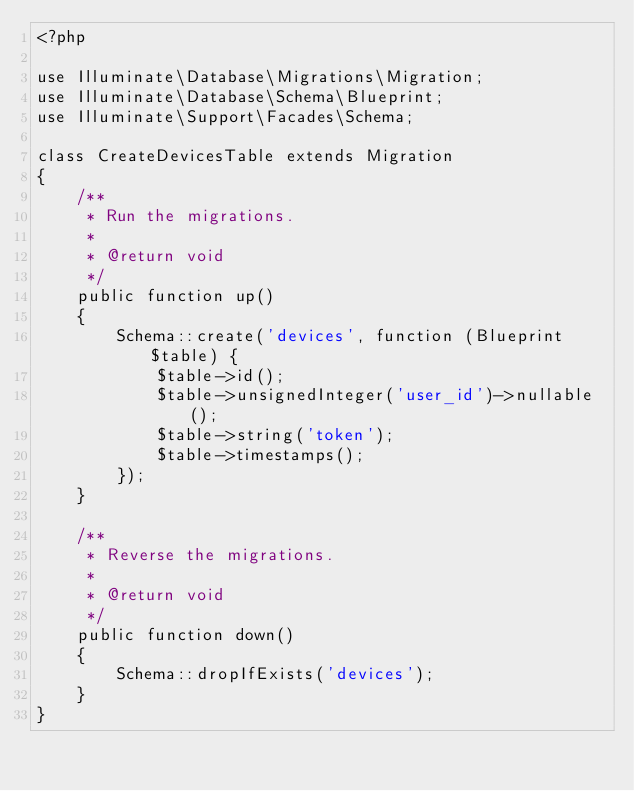<code> <loc_0><loc_0><loc_500><loc_500><_PHP_><?php

use Illuminate\Database\Migrations\Migration;
use Illuminate\Database\Schema\Blueprint;
use Illuminate\Support\Facades\Schema;

class CreateDevicesTable extends Migration
{
    /**
     * Run the migrations.
     *
     * @return void
     */
    public function up()
    {
        Schema::create('devices', function (Blueprint $table) {
            $table->id();
            $table->unsignedInteger('user_id')->nullable();
            $table->string('token');
            $table->timestamps();
        });
    }

    /**
     * Reverse the migrations.
     *
     * @return void
     */
    public function down()
    {
        Schema::dropIfExists('devices');
    }
}
</code> 